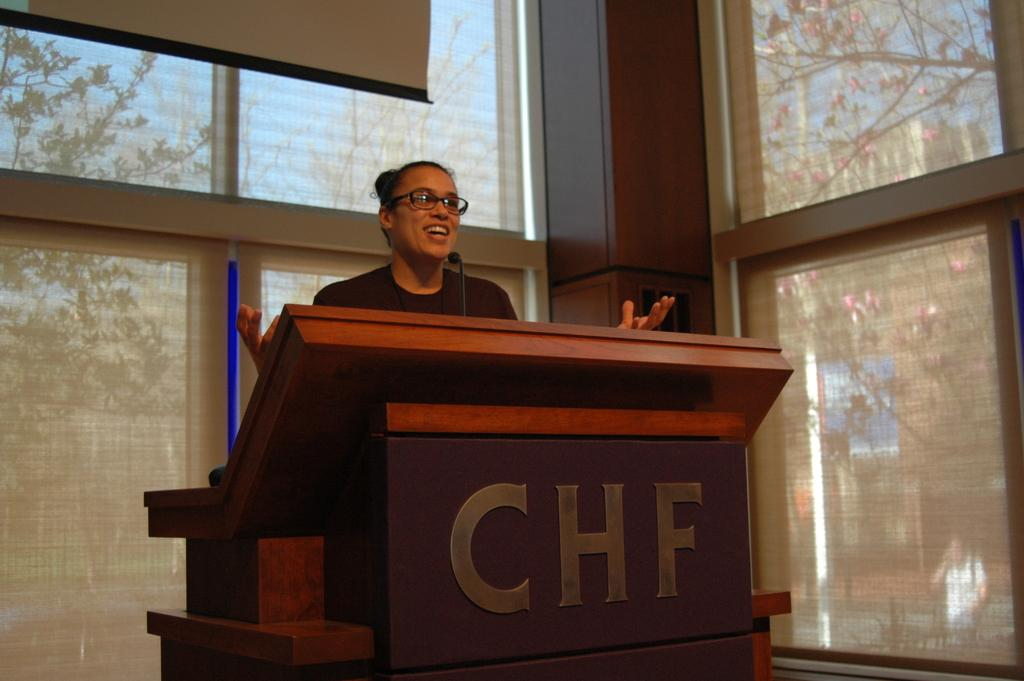What is the person in the image doing? The person is standing in front of a podium. What object is present for the person to use for speaking? There is a microphone (mic) in the image. What can be seen through the windows in the image? Trees are visible through the windows in the image. What is visible in the background of the image? The sky is visible in the image. How many toes are visible on the person's feet in the image? There is no indication of the person's feet or toes in the image. What type of eggs can be seen in the image? There are no eggs present in the image. 